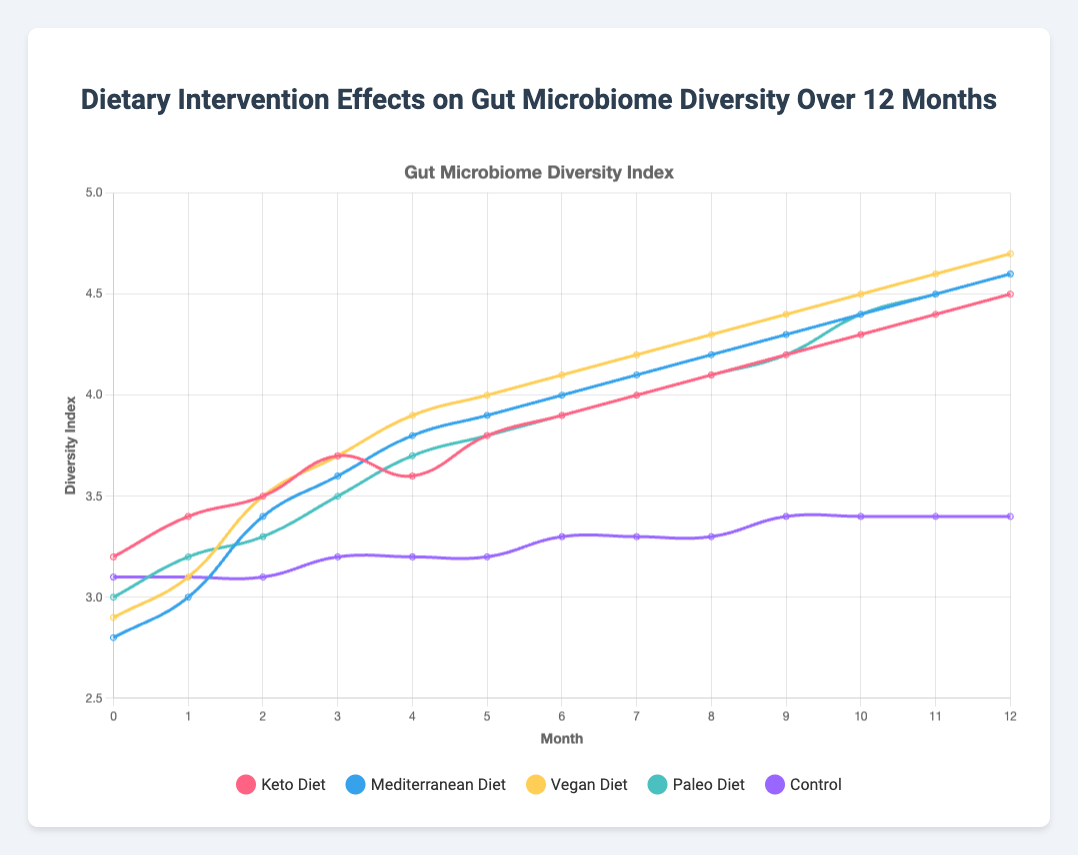What’s the trend in the gut microbiome diversity index of participants following the Keto Diet over 12 months? The line representing the Keto Diet rises steadily from 3.2 at month 0 to 4.5 at month 12. This indicates an overall upward trend in the gut microbiome diversity index for participants following the Keto Diet over the 12-month period.
Answer: Upward trend Which dietary intervention shows the greatest increase in gut microbiome diversity index from month 0 to month 12? By examining the difference between the diversity index at month 12 and month 0 for each dietary intervention: Keto Diet (4.5 - 3.2 = 1.3), Mediterranean Diet (4.6 - 2.8 = 1.8), Vegan Diet (4.7 - 2.9 = 1.8), Paleo Diet (4.6 - 3.0 = 1.6), and Control (3.4 - 3.1 = 0.3). Both the Mediterranean and Vegan diets have the largest increase of 1.8.
Answer: Mediterranean and Vegan Diets How does the microbiome diversity index of participants following the Vegan Diet at month 6 compare to those following the Control at the same month? At month 6, the Vegan Diet has a diversity index of 4.1, while the Control has a diversity index of 3.3. Therefore, the Vegan Diet shows higher microbiome diversity than the Control.
Answer: Vegan Diet is higher What is the average gut microbiome diversity index for the Mediterranean Diet across the 12-month period? Sum the diversity indices for the Mediterranean Diet at each month and divide by 13: (2.8 + 3.0 + 3.4 + 3.6 + 3.8 + 3.9 + 4.0 + 4.1 + 4.2 + 4.3 + 4.4 + 4.5 + 4.6) = 50.6. Then, 50.6/13 = 3.89.
Answer: 3.89 Which diet has the least variation in gut microbiome diversity index over the 12 months? Variation can be seen by the range (difference between maximum and minimum values). Calculate for each: Keto Diet (4.5 - 3.2 = 1.3), Mediterranean Diet (4.6 - 2.8 = 1.8), Vegan Diet (4.7 - 2.9 = 1.8), Paleo Diet (4.6 - 3.0 = 1.6), Control (3.4 - 3.1 = 0.3). The Control group has the least variation.
Answer: Control Which month shows the highest diversity index for the Paleo Diet, and what is the value? Reviewing the Paleo Diet data, the highest diversity index of 4.6 occurs at month 12.
Answer: Month 12 with a value of 4.6 Are there any months where all dietary interventions have higher diversity indices than the Control? Comparing each month, the following months show all interventions higher than Control: months 3 through 12. This can be observed by comparing the lower indices of the Control (3.2 or lower) to higher indices of interventions from month 3 forwards where the indices consistently surpass 3.2.
Answer: Months 3 through 12 What is the median value of the diversity index for the Keto Diet over the entire 12-month period? Arrange the values in ascending order: 3.2, 3.4, 3.5, 3.6, 3.7, 3.8, 3.9, 4.0, 4.1, 4.2, 4.3, 4.4, 4.5. The middle value (7th value) in the sorted list is 3.9.
Answer: 3.9 Between months 4 and 5, which diet shows the greatest increase in the diversity index? Calculate the difference: Keto Diet (3.8 - 3.6 = 0.2), Mediterranean Diet (3.9 - 3.8 = 0.1), Vegan Diet (4.0 - 3.9 = 0.1), Paleo Diet (3.8 - 3.7 = 0.1), Control (3.2 - 3.2 = 0.0). The Keto Diet shows the greatest increase of 0.2.
Answer: Keto Diet By how much does the diversity index for the Mediterranean Diet exceed that of the Paleo Diet at month 11? At month 11, the Mediterranean Diet has a diversity index of 4.5, and the Paleo Diet has 4.5. The Mediterranean Diet exceeds the Paleo Diet by 0.0.
Answer: 0.0 